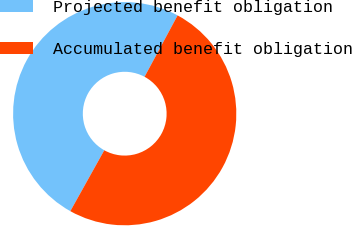Convert chart to OTSL. <chart><loc_0><loc_0><loc_500><loc_500><pie_chart><fcel>Projected benefit obligation<fcel>Accumulated benefit obligation<nl><fcel>49.76%<fcel>50.24%<nl></chart> 